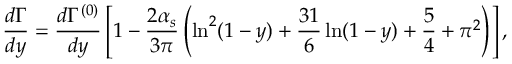<formula> <loc_0><loc_0><loc_500><loc_500>\frac { d \Gamma } { d y } = \frac { d \Gamma ^ { ( 0 ) } } { d y } \left [ 1 - \frac { 2 \alpha _ { s } } { 3 \pi } \left ( \ln ^ { 2 } ( 1 - y ) + \frac { 3 1 } { 6 } \ln ( 1 - y ) + \frac { 5 } { 4 } + \pi ^ { 2 } \right ) \right ] ,</formula> 